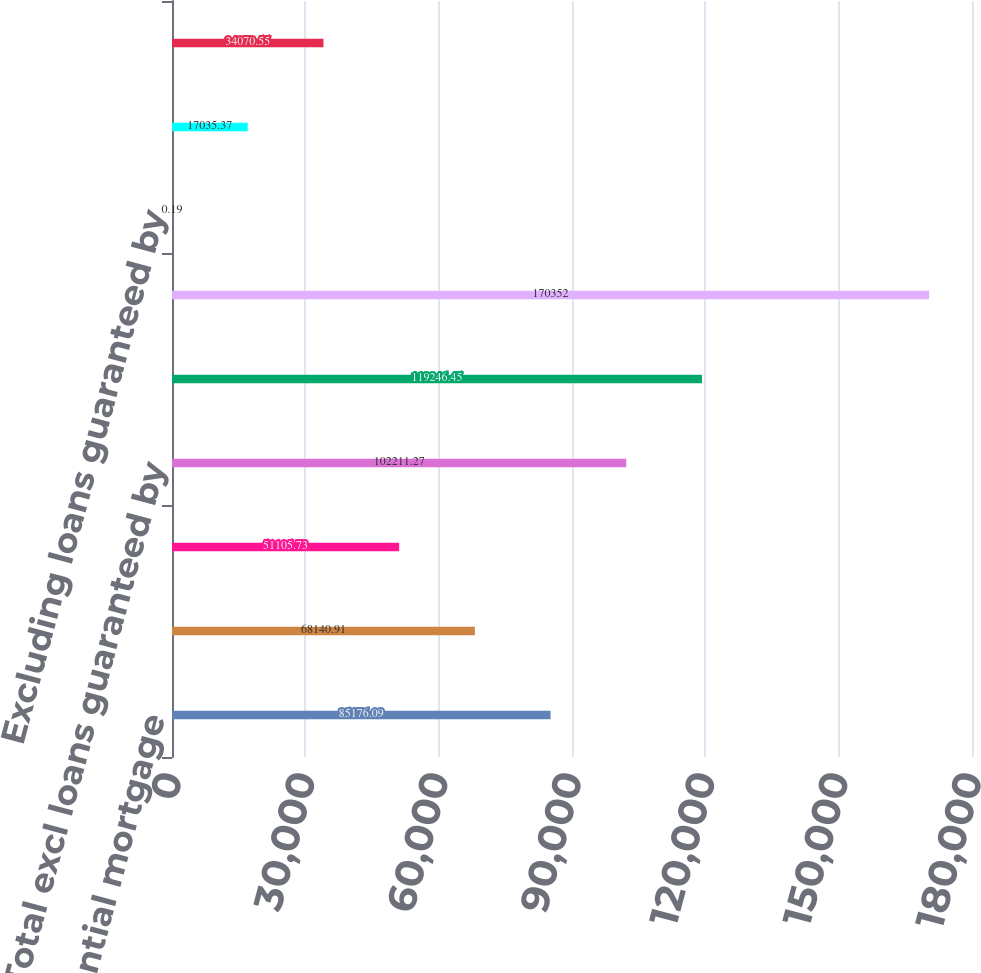Convert chart to OTSL. <chart><loc_0><loc_0><loc_500><loc_500><bar_chart><fcel>Residential mortgage<fcel>Home equity<fcel>Other loans and leases<fcel>Total excl loans guaranteed by<fcel>Add loans guaranteed by the US<fcel>Total accruing loans and<fcel>Excluding loans guaranteed by<fcel>Guaranteed by the US<fcel>Including loans guaranteed by<nl><fcel>85176.1<fcel>68140.9<fcel>51105.7<fcel>102211<fcel>119246<fcel>170352<fcel>0.19<fcel>17035.4<fcel>34070.6<nl></chart> 